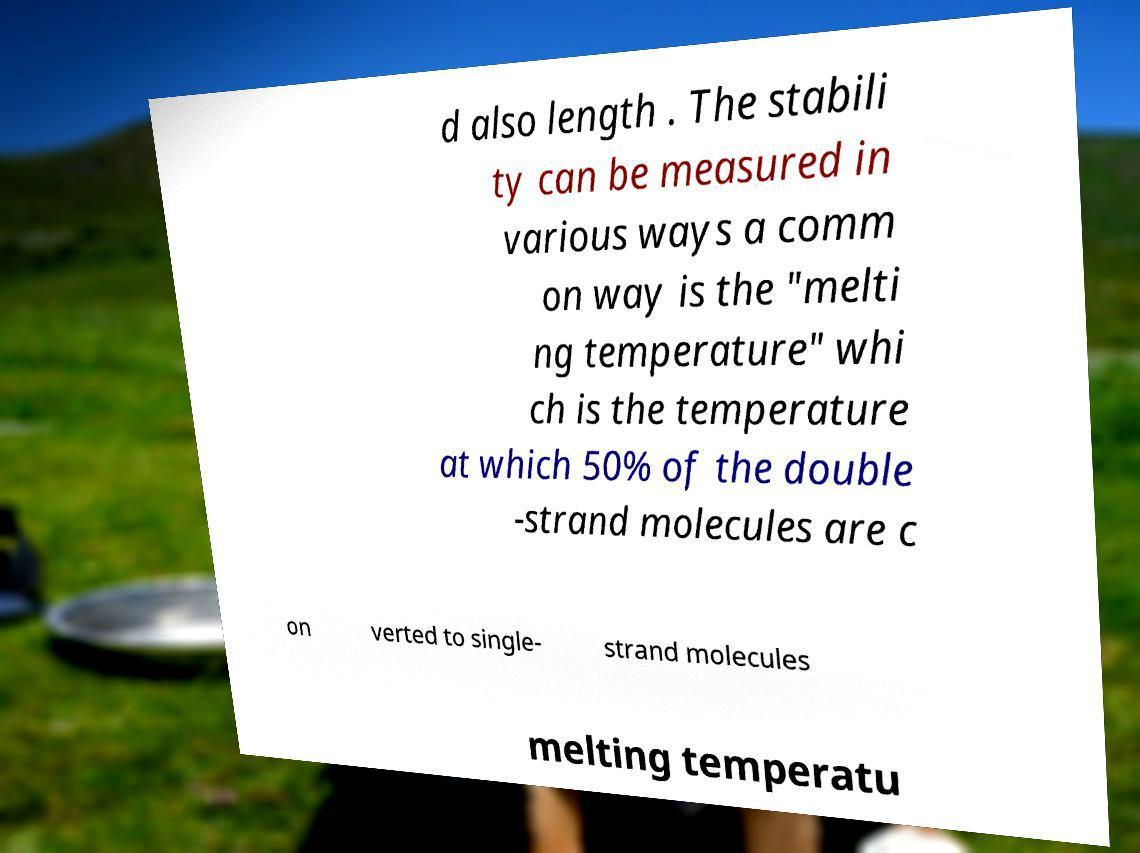Can you accurately transcribe the text from the provided image for me? d also length . The stabili ty can be measured in various ways a comm on way is the "melti ng temperature" whi ch is the temperature at which 50% of the double -strand molecules are c on verted to single- strand molecules melting temperatu 